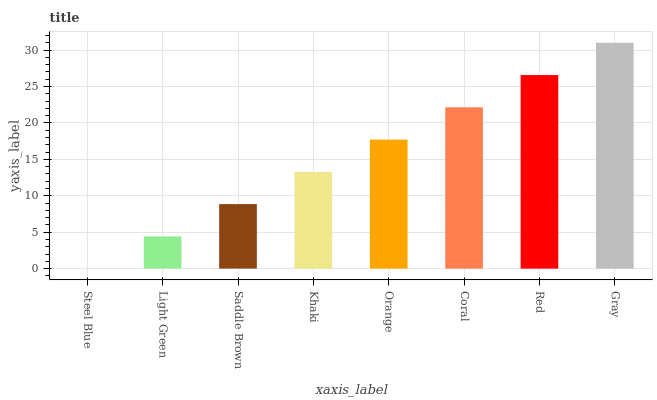Is Steel Blue the minimum?
Answer yes or no. Yes. Is Gray the maximum?
Answer yes or no. Yes. Is Light Green the minimum?
Answer yes or no. No. Is Light Green the maximum?
Answer yes or no. No. Is Light Green greater than Steel Blue?
Answer yes or no. Yes. Is Steel Blue less than Light Green?
Answer yes or no. Yes. Is Steel Blue greater than Light Green?
Answer yes or no. No. Is Light Green less than Steel Blue?
Answer yes or no. No. Is Orange the high median?
Answer yes or no. Yes. Is Khaki the low median?
Answer yes or no. Yes. Is Khaki the high median?
Answer yes or no. No. Is Light Green the low median?
Answer yes or no. No. 